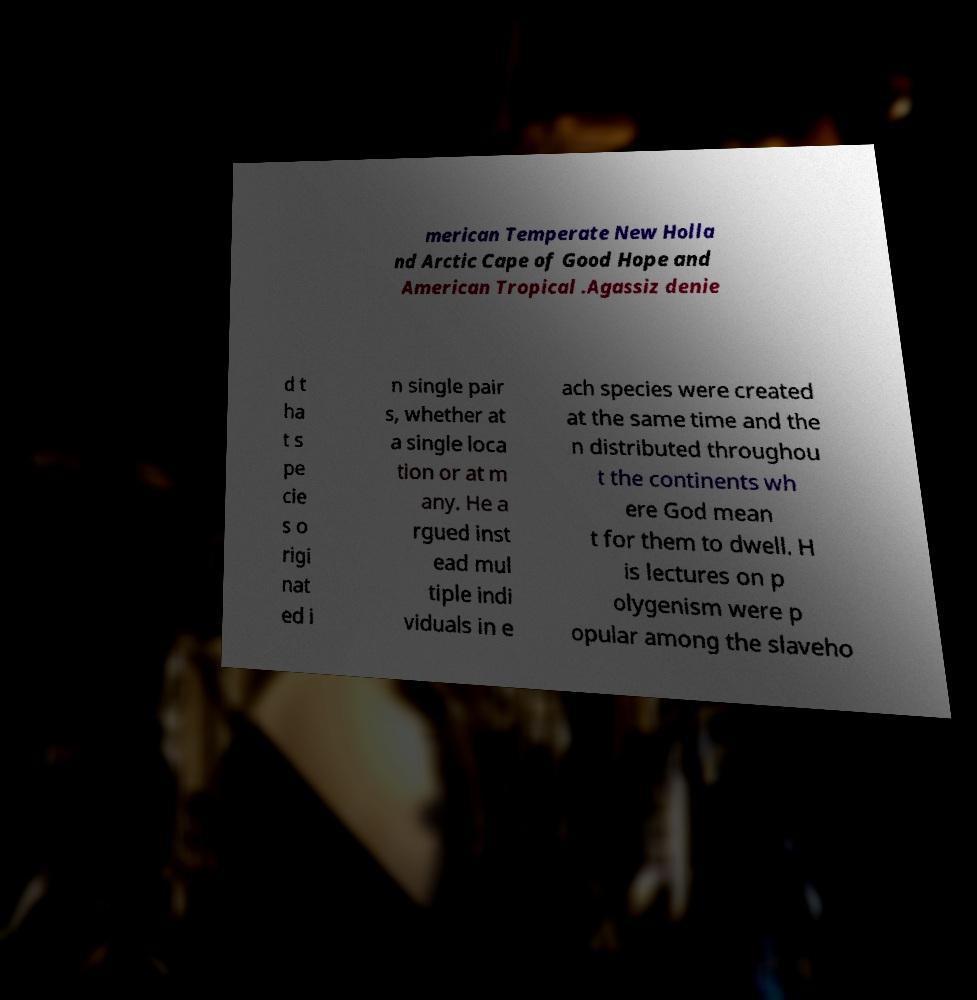What messages or text are displayed in this image? I need them in a readable, typed format. merican Temperate New Holla nd Arctic Cape of Good Hope and American Tropical .Agassiz denie d t ha t s pe cie s o rigi nat ed i n single pair s, whether at a single loca tion or at m any. He a rgued inst ead mul tiple indi viduals in e ach species were created at the same time and the n distributed throughou t the continents wh ere God mean t for them to dwell. H is lectures on p olygenism were p opular among the slaveho 